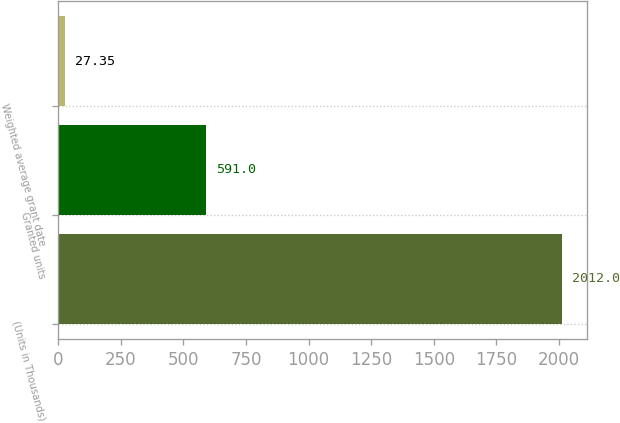<chart> <loc_0><loc_0><loc_500><loc_500><bar_chart><fcel>(Units in Thousands)<fcel>Granted units<fcel>Weighted average grant date<nl><fcel>2012<fcel>591<fcel>27.35<nl></chart> 